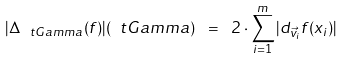Convert formula to latex. <formula><loc_0><loc_0><loc_500><loc_500>| \Delta _ { \ t G a m m a } ( f ) | ( \ t G a m m a ) \ = \ 2 \cdot \sum _ { i = 1 } ^ { m } | d _ { \vec { v } _ { i } } f ( x _ { i } ) |</formula> 